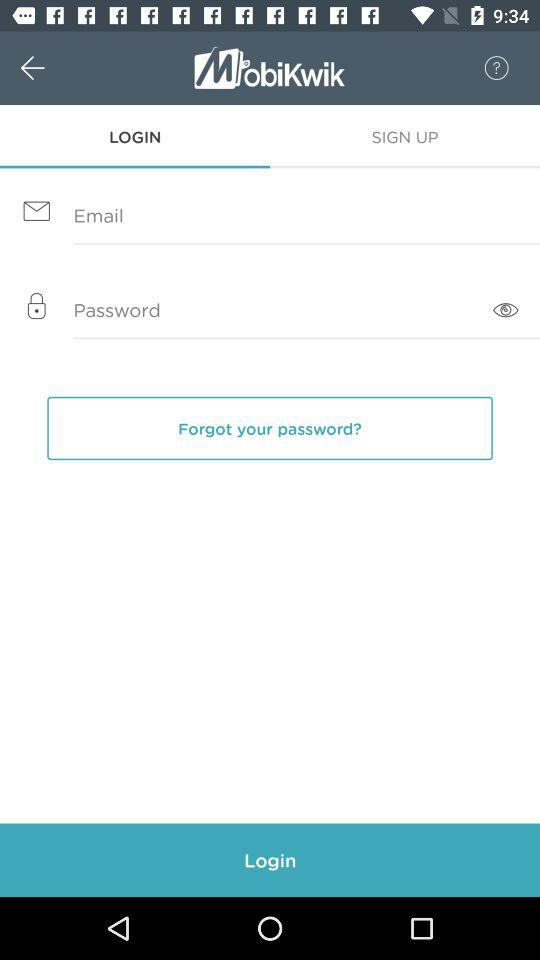Which tab is selected? The selected tab is "LOGIN". 